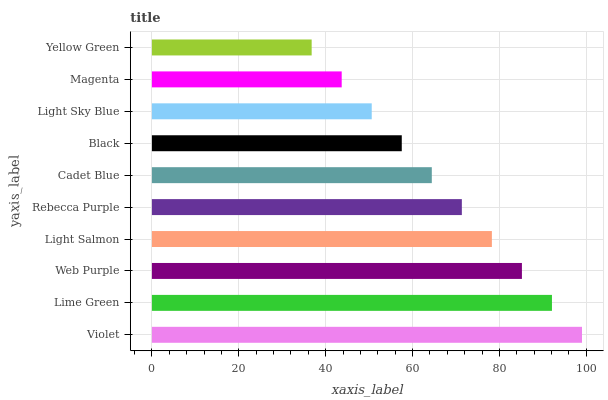Is Yellow Green the minimum?
Answer yes or no. Yes. Is Violet the maximum?
Answer yes or no. Yes. Is Lime Green the minimum?
Answer yes or no. No. Is Lime Green the maximum?
Answer yes or no. No. Is Violet greater than Lime Green?
Answer yes or no. Yes. Is Lime Green less than Violet?
Answer yes or no. Yes. Is Lime Green greater than Violet?
Answer yes or no. No. Is Violet less than Lime Green?
Answer yes or no. No. Is Rebecca Purple the high median?
Answer yes or no. Yes. Is Cadet Blue the low median?
Answer yes or no. Yes. Is Black the high median?
Answer yes or no. No. Is Magenta the low median?
Answer yes or no. No. 